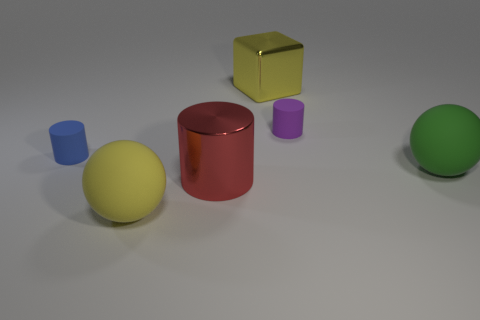How many rubber objects are purple objects or big red objects?
Give a very brief answer. 1. There is a cylinder that is on the left side of the large red metallic object; what is its color?
Keep it short and to the point. Blue. There is another rubber object that is the same size as the purple matte object; what shape is it?
Provide a short and direct response. Cylinder. There is a large cylinder; does it have the same color as the matte cylinder in front of the small purple matte cylinder?
Your answer should be very brief. No. What number of things are either objects behind the green matte sphere or tiny purple cylinders behind the red cylinder?
Give a very brief answer. 3. What is the material of the other object that is the same size as the purple matte object?
Offer a very short reply. Rubber. What number of other objects are the same material as the yellow block?
Your answer should be very brief. 1. There is a object behind the purple cylinder; does it have the same shape as the tiny matte thing that is right of the blue matte thing?
Your response must be concise. No. What is the color of the large metal cylinder that is in front of the sphere that is to the right of the rubber thing in front of the big green sphere?
Make the answer very short. Red. How many other objects are the same color as the shiny block?
Keep it short and to the point. 1. 